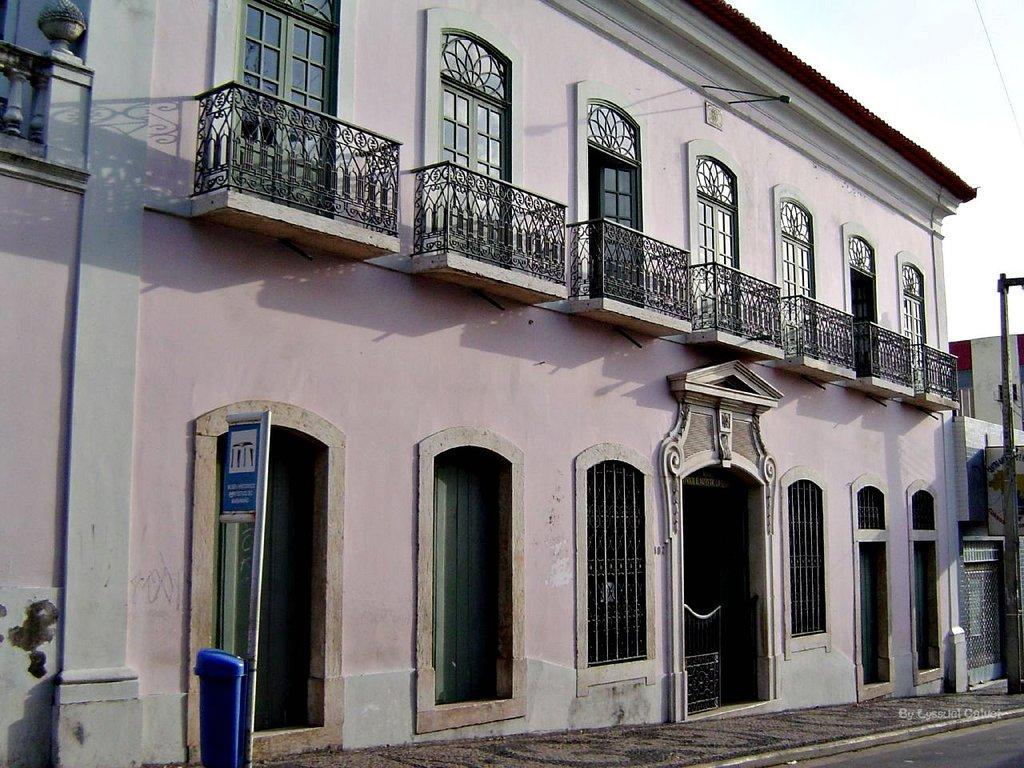What type of structures can be seen in the image? There are buildings in the image. What other objects are present in the image? There are boards, poles, and a wire in the image. Can you describe the blue color thing in the image? There is a blue color thing in the image, and words are written on it. How many planes can be seen flying over the buildings in the image? There are no planes visible in the image; it only shows buildings, boards, poles, a wire, and a blue color thing with words written on it. Are there any geese present in the image? There are no geese present in the image. 